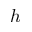<formula> <loc_0><loc_0><loc_500><loc_500>h</formula> 